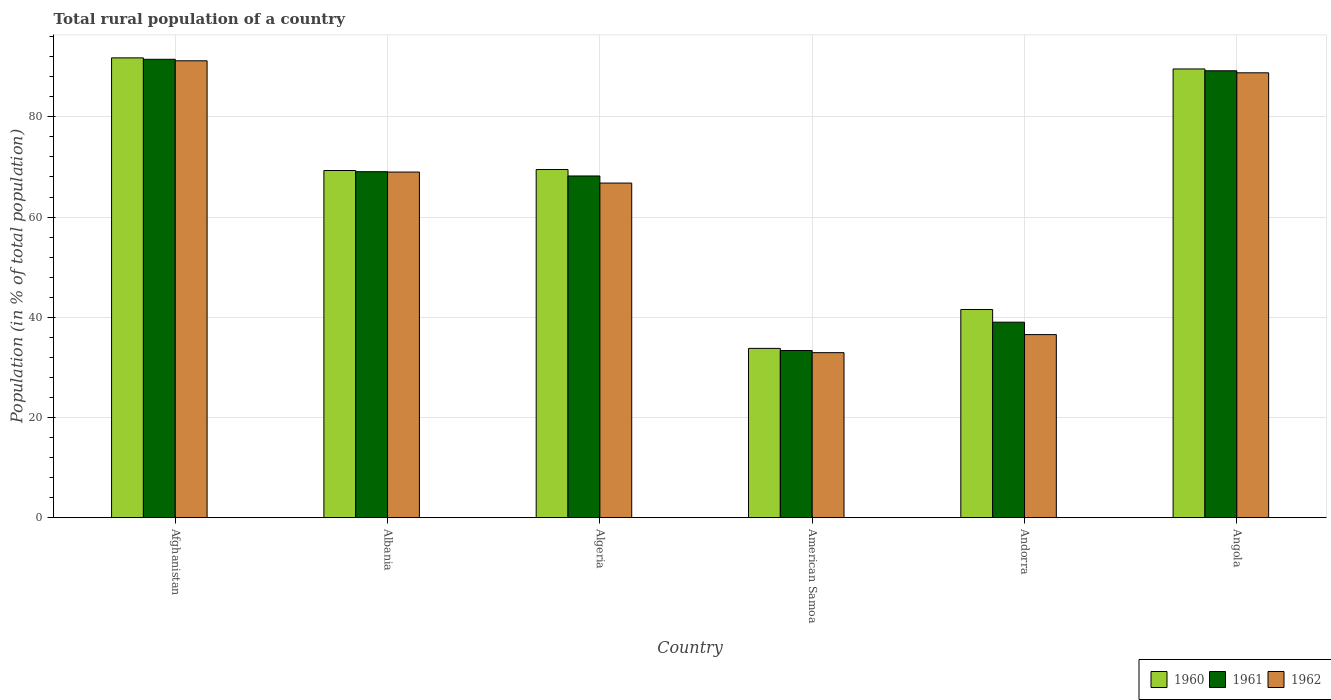How many groups of bars are there?
Your answer should be very brief. 6. How many bars are there on the 6th tick from the left?
Give a very brief answer. 3. What is the label of the 5th group of bars from the left?
Your answer should be very brief. Andorra. In how many cases, is the number of bars for a given country not equal to the number of legend labels?
Your response must be concise. 0. What is the rural population in 1962 in Angola?
Offer a very short reply. 88.8. Across all countries, what is the maximum rural population in 1960?
Ensure brevity in your answer.  91.78. Across all countries, what is the minimum rural population in 1962?
Offer a very short reply. 32.93. In which country was the rural population in 1960 maximum?
Keep it short and to the point. Afghanistan. In which country was the rural population in 1961 minimum?
Your response must be concise. American Samoa. What is the total rural population in 1961 in the graph?
Your answer should be very brief. 390.33. What is the difference between the rural population in 1962 in Albania and that in Andorra?
Offer a very short reply. 32.45. What is the difference between the rural population in 1960 in Algeria and the rural population in 1962 in Angola?
Offer a very short reply. -19.31. What is the average rural population in 1961 per country?
Make the answer very short. 65.05. What is the difference between the rural population of/in 1961 and rural population of/in 1962 in Albania?
Offer a very short reply. 0.07. What is the ratio of the rural population in 1962 in Albania to that in Algeria?
Offer a very short reply. 1.03. Is the rural population in 1961 in Afghanistan less than that in Albania?
Your answer should be very brief. No. Is the difference between the rural population in 1961 in Algeria and Angola greater than the difference between the rural population in 1962 in Algeria and Angola?
Your answer should be very brief. Yes. What is the difference between the highest and the second highest rural population in 1961?
Ensure brevity in your answer.  -2.29. What is the difference between the highest and the lowest rural population in 1962?
Offer a very short reply. 58.26. In how many countries, is the rural population in 1961 greater than the average rural population in 1961 taken over all countries?
Provide a short and direct response. 4. What does the 1st bar from the left in American Samoa represents?
Your answer should be compact. 1960. What does the 2nd bar from the right in Afghanistan represents?
Provide a short and direct response. 1961. How many bars are there?
Offer a terse response. 18. Are all the bars in the graph horizontal?
Ensure brevity in your answer.  No. How many countries are there in the graph?
Your answer should be very brief. 6. What is the difference between two consecutive major ticks on the Y-axis?
Offer a terse response. 20. What is the title of the graph?
Keep it short and to the point. Total rural population of a country. Does "1987" appear as one of the legend labels in the graph?
Your response must be concise. No. What is the label or title of the Y-axis?
Offer a very short reply. Population (in % of total population). What is the Population (in % of total population) in 1960 in Afghanistan?
Give a very brief answer. 91.78. What is the Population (in % of total population) in 1961 in Afghanistan?
Offer a terse response. 91.49. What is the Population (in % of total population) of 1962 in Afghanistan?
Provide a succinct answer. 91.19. What is the Population (in % of total population) in 1960 in Albania?
Make the answer very short. 69.3. What is the Population (in % of total population) of 1961 in Albania?
Provide a short and direct response. 69.06. What is the Population (in % of total population) in 1962 in Albania?
Keep it short and to the point. 68.98. What is the Population (in % of total population) of 1960 in Algeria?
Keep it short and to the point. 69.49. What is the Population (in % of total population) in 1961 in Algeria?
Your response must be concise. 68.2. What is the Population (in % of total population) in 1962 in Algeria?
Offer a terse response. 66.79. What is the Population (in % of total population) in 1960 in American Samoa?
Provide a succinct answer. 33.79. What is the Population (in % of total population) in 1961 in American Samoa?
Provide a succinct answer. 33.36. What is the Population (in % of total population) of 1962 in American Samoa?
Keep it short and to the point. 32.93. What is the Population (in % of total population) in 1960 in Andorra?
Offer a terse response. 41.55. What is the Population (in % of total population) of 1961 in Andorra?
Your answer should be compact. 39.02. What is the Population (in % of total population) in 1962 in Andorra?
Give a very brief answer. 36.54. What is the Population (in % of total population) in 1960 in Angola?
Your answer should be very brief. 89.56. What is the Population (in % of total population) of 1961 in Angola?
Your response must be concise. 89.2. What is the Population (in % of total population) of 1962 in Angola?
Keep it short and to the point. 88.8. Across all countries, what is the maximum Population (in % of total population) of 1960?
Provide a succinct answer. 91.78. Across all countries, what is the maximum Population (in % of total population) in 1961?
Offer a terse response. 91.49. Across all countries, what is the maximum Population (in % of total population) in 1962?
Offer a very short reply. 91.19. Across all countries, what is the minimum Population (in % of total population) of 1960?
Offer a terse response. 33.79. Across all countries, what is the minimum Population (in % of total population) in 1961?
Your response must be concise. 33.36. Across all countries, what is the minimum Population (in % of total population) of 1962?
Keep it short and to the point. 32.93. What is the total Population (in % of total population) of 1960 in the graph?
Offer a very short reply. 395.47. What is the total Population (in % of total population) of 1961 in the graph?
Offer a very short reply. 390.33. What is the total Population (in % of total population) of 1962 in the graph?
Give a very brief answer. 385.23. What is the difference between the Population (in % of total population) of 1960 in Afghanistan and that in Albania?
Your answer should be very brief. 22.48. What is the difference between the Population (in % of total population) in 1961 in Afghanistan and that in Albania?
Offer a terse response. 22.43. What is the difference between the Population (in % of total population) of 1962 in Afghanistan and that in Albania?
Give a very brief answer. 22.21. What is the difference between the Population (in % of total population) in 1960 in Afghanistan and that in Algeria?
Keep it short and to the point. 22.29. What is the difference between the Population (in % of total population) of 1961 in Afghanistan and that in Algeria?
Provide a succinct answer. 23.29. What is the difference between the Population (in % of total population) in 1962 in Afghanistan and that in Algeria?
Your answer should be compact. 24.41. What is the difference between the Population (in % of total population) of 1960 in Afghanistan and that in American Samoa?
Provide a short and direct response. 57.99. What is the difference between the Population (in % of total population) of 1961 in Afghanistan and that in American Samoa?
Your answer should be compact. 58.13. What is the difference between the Population (in % of total population) of 1962 in Afghanistan and that in American Samoa?
Offer a very short reply. 58.26. What is the difference between the Population (in % of total population) in 1960 in Afghanistan and that in Andorra?
Your response must be concise. 50.23. What is the difference between the Population (in % of total population) of 1961 in Afghanistan and that in Andorra?
Offer a very short reply. 52.48. What is the difference between the Population (in % of total population) of 1962 in Afghanistan and that in Andorra?
Provide a succinct answer. 54.66. What is the difference between the Population (in % of total population) in 1960 in Afghanistan and that in Angola?
Offer a very short reply. 2.21. What is the difference between the Population (in % of total population) in 1961 in Afghanistan and that in Angola?
Offer a terse response. 2.29. What is the difference between the Population (in % of total population) of 1962 in Afghanistan and that in Angola?
Provide a short and direct response. 2.4. What is the difference between the Population (in % of total population) in 1960 in Albania and that in Algeria?
Your response must be concise. -0.2. What is the difference between the Population (in % of total population) in 1961 in Albania and that in Algeria?
Provide a short and direct response. 0.85. What is the difference between the Population (in % of total population) in 1962 in Albania and that in Algeria?
Your answer should be compact. 2.2. What is the difference between the Population (in % of total population) in 1960 in Albania and that in American Samoa?
Your response must be concise. 35.51. What is the difference between the Population (in % of total population) in 1961 in Albania and that in American Samoa?
Provide a succinct answer. 35.7. What is the difference between the Population (in % of total population) of 1962 in Albania and that in American Samoa?
Give a very brief answer. 36.05. What is the difference between the Population (in % of total population) of 1960 in Albania and that in Andorra?
Your response must be concise. 27.75. What is the difference between the Population (in % of total population) of 1961 in Albania and that in Andorra?
Give a very brief answer. 30.04. What is the difference between the Population (in % of total population) in 1962 in Albania and that in Andorra?
Offer a terse response. 32.45. What is the difference between the Population (in % of total population) in 1960 in Albania and that in Angola?
Your response must be concise. -20.27. What is the difference between the Population (in % of total population) in 1961 in Albania and that in Angola?
Your response must be concise. -20.14. What is the difference between the Population (in % of total population) of 1962 in Albania and that in Angola?
Your answer should be compact. -19.81. What is the difference between the Population (in % of total population) of 1960 in Algeria and that in American Samoa?
Your answer should be very brief. 35.7. What is the difference between the Population (in % of total population) of 1961 in Algeria and that in American Samoa?
Your response must be concise. 34.84. What is the difference between the Population (in % of total population) of 1962 in Algeria and that in American Samoa?
Offer a terse response. 33.85. What is the difference between the Population (in % of total population) of 1960 in Algeria and that in Andorra?
Offer a terse response. 27.94. What is the difference between the Population (in % of total population) of 1961 in Algeria and that in Andorra?
Provide a succinct answer. 29.19. What is the difference between the Population (in % of total population) of 1962 in Algeria and that in Andorra?
Ensure brevity in your answer.  30.25. What is the difference between the Population (in % of total population) in 1960 in Algeria and that in Angola?
Offer a very short reply. -20.07. What is the difference between the Population (in % of total population) in 1961 in Algeria and that in Angola?
Your response must be concise. -21. What is the difference between the Population (in % of total population) in 1962 in Algeria and that in Angola?
Make the answer very short. -22.01. What is the difference between the Population (in % of total population) in 1960 in American Samoa and that in Andorra?
Keep it short and to the point. -7.76. What is the difference between the Population (in % of total population) in 1961 in American Samoa and that in Andorra?
Your answer should be very brief. -5.66. What is the difference between the Population (in % of total population) of 1962 in American Samoa and that in Andorra?
Provide a succinct answer. -3.61. What is the difference between the Population (in % of total population) in 1960 in American Samoa and that in Angola?
Give a very brief answer. -55.78. What is the difference between the Population (in % of total population) in 1961 in American Samoa and that in Angola?
Provide a short and direct response. -55.84. What is the difference between the Population (in % of total population) in 1962 in American Samoa and that in Angola?
Provide a short and direct response. -55.86. What is the difference between the Population (in % of total population) of 1960 in Andorra and that in Angola?
Give a very brief answer. -48.02. What is the difference between the Population (in % of total population) of 1961 in Andorra and that in Angola?
Give a very brief answer. -50.19. What is the difference between the Population (in % of total population) of 1962 in Andorra and that in Angola?
Offer a terse response. -52.26. What is the difference between the Population (in % of total population) of 1960 in Afghanistan and the Population (in % of total population) of 1961 in Albania?
Offer a terse response. 22.72. What is the difference between the Population (in % of total population) in 1960 in Afghanistan and the Population (in % of total population) in 1962 in Albania?
Make the answer very short. 22.79. What is the difference between the Population (in % of total population) in 1961 in Afghanistan and the Population (in % of total population) in 1962 in Albania?
Your answer should be compact. 22.51. What is the difference between the Population (in % of total population) of 1960 in Afghanistan and the Population (in % of total population) of 1961 in Algeria?
Give a very brief answer. 23.58. What is the difference between the Population (in % of total population) of 1960 in Afghanistan and the Population (in % of total population) of 1962 in Algeria?
Provide a short and direct response. 24.99. What is the difference between the Population (in % of total population) of 1961 in Afghanistan and the Population (in % of total population) of 1962 in Algeria?
Make the answer very short. 24.71. What is the difference between the Population (in % of total population) in 1960 in Afghanistan and the Population (in % of total population) in 1961 in American Samoa?
Make the answer very short. 58.42. What is the difference between the Population (in % of total population) of 1960 in Afghanistan and the Population (in % of total population) of 1962 in American Samoa?
Keep it short and to the point. 58.85. What is the difference between the Population (in % of total population) of 1961 in Afghanistan and the Population (in % of total population) of 1962 in American Samoa?
Keep it short and to the point. 58.56. What is the difference between the Population (in % of total population) in 1960 in Afghanistan and the Population (in % of total population) in 1961 in Andorra?
Provide a succinct answer. 52.76. What is the difference between the Population (in % of total population) in 1960 in Afghanistan and the Population (in % of total population) in 1962 in Andorra?
Make the answer very short. 55.24. What is the difference between the Population (in % of total population) of 1961 in Afghanistan and the Population (in % of total population) of 1962 in Andorra?
Make the answer very short. 54.95. What is the difference between the Population (in % of total population) of 1960 in Afghanistan and the Population (in % of total population) of 1961 in Angola?
Your response must be concise. 2.58. What is the difference between the Population (in % of total population) of 1960 in Afghanistan and the Population (in % of total population) of 1962 in Angola?
Keep it short and to the point. 2.98. What is the difference between the Population (in % of total population) in 1961 in Afghanistan and the Population (in % of total population) in 1962 in Angola?
Your response must be concise. 2.7. What is the difference between the Population (in % of total population) of 1960 in Albania and the Population (in % of total population) of 1961 in Algeria?
Ensure brevity in your answer.  1.09. What is the difference between the Population (in % of total population) of 1960 in Albania and the Population (in % of total population) of 1962 in Algeria?
Keep it short and to the point. 2.51. What is the difference between the Population (in % of total population) in 1961 in Albania and the Population (in % of total population) in 1962 in Algeria?
Your answer should be compact. 2.27. What is the difference between the Population (in % of total population) in 1960 in Albania and the Population (in % of total population) in 1961 in American Samoa?
Keep it short and to the point. 35.94. What is the difference between the Population (in % of total population) in 1960 in Albania and the Population (in % of total population) in 1962 in American Samoa?
Your answer should be very brief. 36.36. What is the difference between the Population (in % of total population) of 1961 in Albania and the Population (in % of total population) of 1962 in American Samoa?
Offer a very short reply. 36.12. What is the difference between the Population (in % of total population) of 1960 in Albania and the Population (in % of total population) of 1961 in Andorra?
Provide a short and direct response. 30.28. What is the difference between the Population (in % of total population) of 1960 in Albania and the Population (in % of total population) of 1962 in Andorra?
Ensure brevity in your answer.  32.76. What is the difference between the Population (in % of total population) of 1961 in Albania and the Population (in % of total population) of 1962 in Andorra?
Keep it short and to the point. 32.52. What is the difference between the Population (in % of total population) in 1960 in Albania and the Population (in % of total population) in 1961 in Angola?
Provide a succinct answer. -19.91. What is the difference between the Population (in % of total population) in 1960 in Albania and the Population (in % of total population) in 1962 in Angola?
Make the answer very short. -19.5. What is the difference between the Population (in % of total population) in 1961 in Albania and the Population (in % of total population) in 1962 in Angola?
Ensure brevity in your answer.  -19.74. What is the difference between the Population (in % of total population) in 1960 in Algeria and the Population (in % of total population) in 1961 in American Samoa?
Your response must be concise. 36.13. What is the difference between the Population (in % of total population) in 1960 in Algeria and the Population (in % of total population) in 1962 in American Samoa?
Your response must be concise. 36.56. What is the difference between the Population (in % of total population) of 1961 in Algeria and the Population (in % of total population) of 1962 in American Samoa?
Give a very brief answer. 35.27. What is the difference between the Population (in % of total population) in 1960 in Algeria and the Population (in % of total population) in 1961 in Andorra?
Offer a very short reply. 30.47. What is the difference between the Population (in % of total population) in 1960 in Algeria and the Population (in % of total population) in 1962 in Andorra?
Keep it short and to the point. 32.95. What is the difference between the Population (in % of total population) of 1961 in Algeria and the Population (in % of total population) of 1962 in Andorra?
Offer a very short reply. 31.66. What is the difference between the Population (in % of total population) of 1960 in Algeria and the Population (in % of total population) of 1961 in Angola?
Your answer should be compact. -19.71. What is the difference between the Population (in % of total population) in 1960 in Algeria and the Population (in % of total population) in 1962 in Angola?
Your answer should be very brief. -19.31. What is the difference between the Population (in % of total population) in 1961 in Algeria and the Population (in % of total population) in 1962 in Angola?
Offer a terse response. -20.59. What is the difference between the Population (in % of total population) in 1960 in American Samoa and the Population (in % of total population) in 1961 in Andorra?
Offer a terse response. -5.23. What is the difference between the Population (in % of total population) of 1960 in American Samoa and the Population (in % of total population) of 1962 in Andorra?
Ensure brevity in your answer.  -2.75. What is the difference between the Population (in % of total population) in 1961 in American Samoa and the Population (in % of total population) in 1962 in Andorra?
Give a very brief answer. -3.18. What is the difference between the Population (in % of total population) of 1960 in American Samoa and the Population (in % of total population) of 1961 in Angola?
Your answer should be very brief. -55.41. What is the difference between the Population (in % of total population) of 1960 in American Samoa and the Population (in % of total population) of 1962 in Angola?
Provide a succinct answer. -55.01. What is the difference between the Population (in % of total population) of 1961 in American Samoa and the Population (in % of total population) of 1962 in Angola?
Offer a terse response. -55.44. What is the difference between the Population (in % of total population) of 1960 in Andorra and the Population (in % of total population) of 1961 in Angola?
Offer a very short reply. -47.65. What is the difference between the Population (in % of total population) of 1960 in Andorra and the Population (in % of total population) of 1962 in Angola?
Offer a terse response. -47.25. What is the difference between the Population (in % of total population) of 1961 in Andorra and the Population (in % of total population) of 1962 in Angola?
Ensure brevity in your answer.  -49.78. What is the average Population (in % of total population) in 1960 per country?
Make the answer very short. 65.91. What is the average Population (in % of total population) of 1961 per country?
Your response must be concise. 65.06. What is the average Population (in % of total population) in 1962 per country?
Give a very brief answer. 64.21. What is the difference between the Population (in % of total population) of 1960 and Population (in % of total population) of 1961 in Afghanistan?
Offer a very short reply. 0.29. What is the difference between the Population (in % of total population) in 1960 and Population (in % of total population) in 1962 in Afghanistan?
Offer a terse response. 0.58. What is the difference between the Population (in % of total population) in 1961 and Population (in % of total population) in 1962 in Afghanistan?
Ensure brevity in your answer.  0.3. What is the difference between the Population (in % of total population) of 1960 and Population (in % of total population) of 1961 in Albania?
Provide a succinct answer. 0.24. What is the difference between the Population (in % of total population) of 1960 and Population (in % of total population) of 1962 in Albania?
Make the answer very short. 0.31. What is the difference between the Population (in % of total population) of 1961 and Population (in % of total population) of 1962 in Albania?
Make the answer very short. 0.07. What is the difference between the Population (in % of total population) of 1960 and Population (in % of total population) of 1961 in Algeria?
Offer a very short reply. 1.29. What is the difference between the Population (in % of total population) in 1960 and Population (in % of total population) in 1962 in Algeria?
Provide a short and direct response. 2.7. What is the difference between the Population (in % of total population) of 1961 and Population (in % of total population) of 1962 in Algeria?
Ensure brevity in your answer.  1.42. What is the difference between the Population (in % of total population) in 1960 and Population (in % of total population) in 1961 in American Samoa?
Make the answer very short. 0.43. What is the difference between the Population (in % of total population) in 1960 and Population (in % of total population) in 1962 in American Samoa?
Give a very brief answer. 0.86. What is the difference between the Population (in % of total population) in 1961 and Population (in % of total population) in 1962 in American Samoa?
Your answer should be compact. 0.43. What is the difference between the Population (in % of total population) of 1960 and Population (in % of total population) of 1961 in Andorra?
Your answer should be compact. 2.53. What is the difference between the Population (in % of total population) of 1960 and Population (in % of total population) of 1962 in Andorra?
Make the answer very short. 5.01. What is the difference between the Population (in % of total population) in 1961 and Population (in % of total population) in 1962 in Andorra?
Offer a terse response. 2.48. What is the difference between the Population (in % of total population) in 1960 and Population (in % of total population) in 1961 in Angola?
Offer a terse response. 0.36. What is the difference between the Population (in % of total population) of 1960 and Population (in % of total population) of 1962 in Angola?
Your answer should be very brief. 0.77. What is the difference between the Population (in % of total population) of 1961 and Population (in % of total population) of 1962 in Angola?
Your response must be concise. 0.41. What is the ratio of the Population (in % of total population) in 1960 in Afghanistan to that in Albania?
Ensure brevity in your answer.  1.32. What is the ratio of the Population (in % of total population) of 1961 in Afghanistan to that in Albania?
Make the answer very short. 1.32. What is the ratio of the Population (in % of total population) of 1962 in Afghanistan to that in Albania?
Your answer should be very brief. 1.32. What is the ratio of the Population (in % of total population) in 1960 in Afghanistan to that in Algeria?
Your answer should be compact. 1.32. What is the ratio of the Population (in % of total population) of 1961 in Afghanistan to that in Algeria?
Provide a short and direct response. 1.34. What is the ratio of the Population (in % of total population) of 1962 in Afghanistan to that in Algeria?
Make the answer very short. 1.37. What is the ratio of the Population (in % of total population) of 1960 in Afghanistan to that in American Samoa?
Provide a short and direct response. 2.72. What is the ratio of the Population (in % of total population) in 1961 in Afghanistan to that in American Samoa?
Give a very brief answer. 2.74. What is the ratio of the Population (in % of total population) of 1962 in Afghanistan to that in American Samoa?
Your answer should be very brief. 2.77. What is the ratio of the Population (in % of total population) in 1960 in Afghanistan to that in Andorra?
Your answer should be compact. 2.21. What is the ratio of the Population (in % of total population) in 1961 in Afghanistan to that in Andorra?
Offer a very short reply. 2.34. What is the ratio of the Population (in % of total population) of 1962 in Afghanistan to that in Andorra?
Your answer should be compact. 2.5. What is the ratio of the Population (in % of total population) of 1960 in Afghanistan to that in Angola?
Keep it short and to the point. 1.02. What is the ratio of the Population (in % of total population) of 1961 in Afghanistan to that in Angola?
Make the answer very short. 1.03. What is the ratio of the Population (in % of total population) of 1962 in Afghanistan to that in Angola?
Keep it short and to the point. 1.03. What is the ratio of the Population (in % of total population) of 1960 in Albania to that in Algeria?
Keep it short and to the point. 1. What is the ratio of the Population (in % of total population) in 1961 in Albania to that in Algeria?
Offer a terse response. 1.01. What is the ratio of the Population (in % of total population) of 1962 in Albania to that in Algeria?
Ensure brevity in your answer.  1.03. What is the ratio of the Population (in % of total population) of 1960 in Albania to that in American Samoa?
Make the answer very short. 2.05. What is the ratio of the Population (in % of total population) of 1961 in Albania to that in American Samoa?
Keep it short and to the point. 2.07. What is the ratio of the Population (in % of total population) in 1962 in Albania to that in American Samoa?
Your answer should be very brief. 2.09. What is the ratio of the Population (in % of total population) of 1960 in Albania to that in Andorra?
Your answer should be compact. 1.67. What is the ratio of the Population (in % of total population) in 1961 in Albania to that in Andorra?
Ensure brevity in your answer.  1.77. What is the ratio of the Population (in % of total population) in 1962 in Albania to that in Andorra?
Make the answer very short. 1.89. What is the ratio of the Population (in % of total population) of 1960 in Albania to that in Angola?
Make the answer very short. 0.77. What is the ratio of the Population (in % of total population) in 1961 in Albania to that in Angola?
Offer a very short reply. 0.77. What is the ratio of the Population (in % of total population) of 1962 in Albania to that in Angola?
Keep it short and to the point. 0.78. What is the ratio of the Population (in % of total population) in 1960 in Algeria to that in American Samoa?
Give a very brief answer. 2.06. What is the ratio of the Population (in % of total population) in 1961 in Algeria to that in American Samoa?
Your answer should be very brief. 2.04. What is the ratio of the Population (in % of total population) of 1962 in Algeria to that in American Samoa?
Ensure brevity in your answer.  2.03. What is the ratio of the Population (in % of total population) of 1960 in Algeria to that in Andorra?
Offer a terse response. 1.67. What is the ratio of the Population (in % of total population) in 1961 in Algeria to that in Andorra?
Offer a terse response. 1.75. What is the ratio of the Population (in % of total population) of 1962 in Algeria to that in Andorra?
Your answer should be very brief. 1.83. What is the ratio of the Population (in % of total population) of 1960 in Algeria to that in Angola?
Your answer should be compact. 0.78. What is the ratio of the Population (in % of total population) of 1961 in Algeria to that in Angola?
Provide a succinct answer. 0.76. What is the ratio of the Population (in % of total population) of 1962 in Algeria to that in Angola?
Make the answer very short. 0.75. What is the ratio of the Population (in % of total population) in 1960 in American Samoa to that in Andorra?
Offer a very short reply. 0.81. What is the ratio of the Population (in % of total population) of 1961 in American Samoa to that in Andorra?
Give a very brief answer. 0.85. What is the ratio of the Population (in % of total population) of 1962 in American Samoa to that in Andorra?
Provide a succinct answer. 0.9. What is the ratio of the Population (in % of total population) in 1960 in American Samoa to that in Angola?
Offer a terse response. 0.38. What is the ratio of the Population (in % of total population) of 1961 in American Samoa to that in Angola?
Provide a short and direct response. 0.37. What is the ratio of the Population (in % of total population) of 1962 in American Samoa to that in Angola?
Your answer should be compact. 0.37. What is the ratio of the Population (in % of total population) of 1960 in Andorra to that in Angola?
Your answer should be compact. 0.46. What is the ratio of the Population (in % of total population) of 1961 in Andorra to that in Angola?
Your response must be concise. 0.44. What is the ratio of the Population (in % of total population) in 1962 in Andorra to that in Angola?
Provide a short and direct response. 0.41. What is the difference between the highest and the second highest Population (in % of total population) of 1960?
Offer a very short reply. 2.21. What is the difference between the highest and the second highest Population (in % of total population) in 1961?
Ensure brevity in your answer.  2.29. What is the difference between the highest and the second highest Population (in % of total population) of 1962?
Provide a short and direct response. 2.4. What is the difference between the highest and the lowest Population (in % of total population) of 1960?
Offer a very short reply. 57.99. What is the difference between the highest and the lowest Population (in % of total population) of 1961?
Keep it short and to the point. 58.13. What is the difference between the highest and the lowest Population (in % of total population) in 1962?
Give a very brief answer. 58.26. 